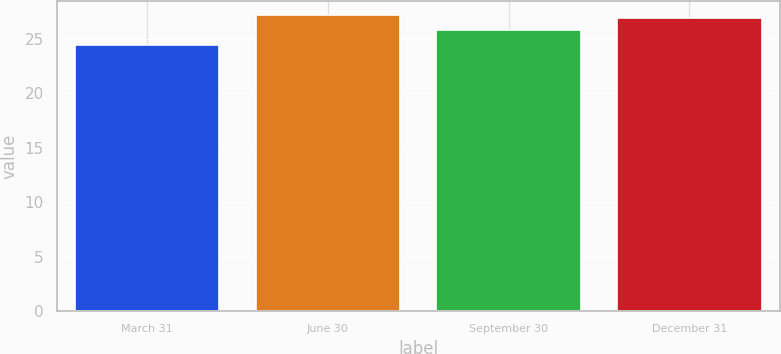Convert chart to OTSL. <chart><loc_0><loc_0><loc_500><loc_500><bar_chart><fcel>March 31<fcel>June 30<fcel>September 30<fcel>December 31<nl><fcel>24.4<fcel>27.15<fcel>25.77<fcel>26.9<nl></chart> 